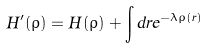Convert formula to latex. <formula><loc_0><loc_0><loc_500><loc_500>H ^ { \prime } ( \rho ) = H ( \rho ) + \int d r e ^ { - \lambda \rho ( r ) }</formula> 